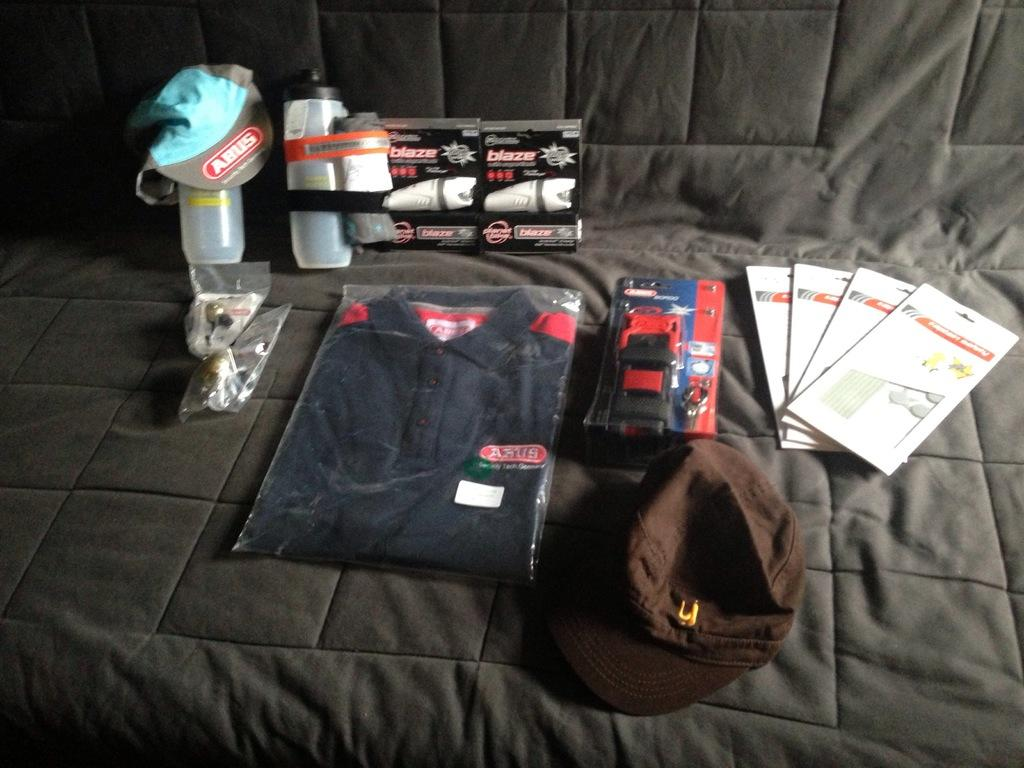What type of clothing item is visible in the image? There is a T-shirt in the image. What else can be seen in the image besides the T-shirt? There are bottles and caps visible in the image. Can you describe the other objects in the image? There are other objects in the image, but their specific details are not mentioned in the provided facts. On what object are these items placed? These objects are placed on another object, but the nature of that object is not mentioned in the provided facts. Where is the faucet located in the image? There is no faucet present in the image. What type of ball is being used to play with the other objects in the image? There is no ball present in the image. 